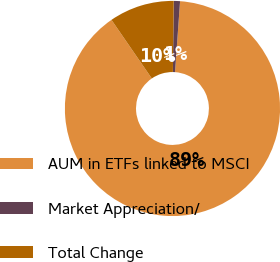<chart> <loc_0><loc_0><loc_500><loc_500><pie_chart><fcel>AUM in ETFs linked to MSCI<fcel>Market Appreciation/<fcel>Total Change<nl><fcel>89.28%<fcel>0.94%<fcel>9.78%<nl></chart> 